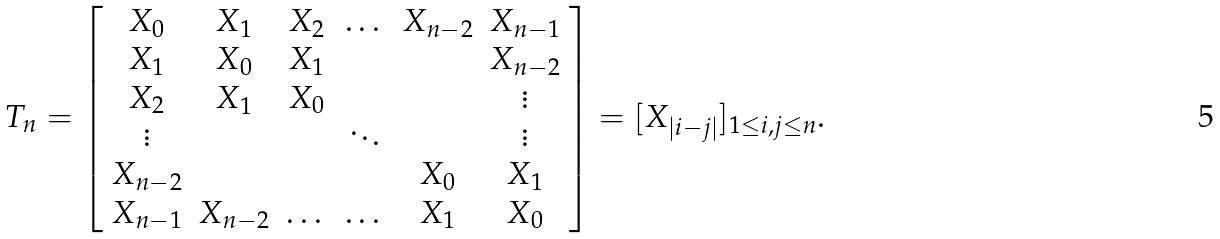<formula> <loc_0><loc_0><loc_500><loc_500>T _ { n } = \left [ \begin{array} { c c c c c c } X _ { 0 } & X _ { 1 } & X _ { 2 } & \dots & X _ { n - 2 } & X _ { n - 1 } \\ X _ { 1 } & X _ { 0 } & X _ { 1 } & & & X _ { n - 2 } \\ X _ { 2 } & X _ { 1 } & X _ { 0 } & & & \vdots \\ \vdots & & & \ddots & & \vdots \\ X _ { n - 2 } & & & & X _ { 0 } & X _ { 1 } \\ X _ { n - 1 } & X _ { n - 2 } & \dots & \dots & X _ { 1 } & X _ { 0 } \end{array} \right ] = [ X _ { | i - j | } ] _ { 1 \leq i , j \leq n } .</formula> 